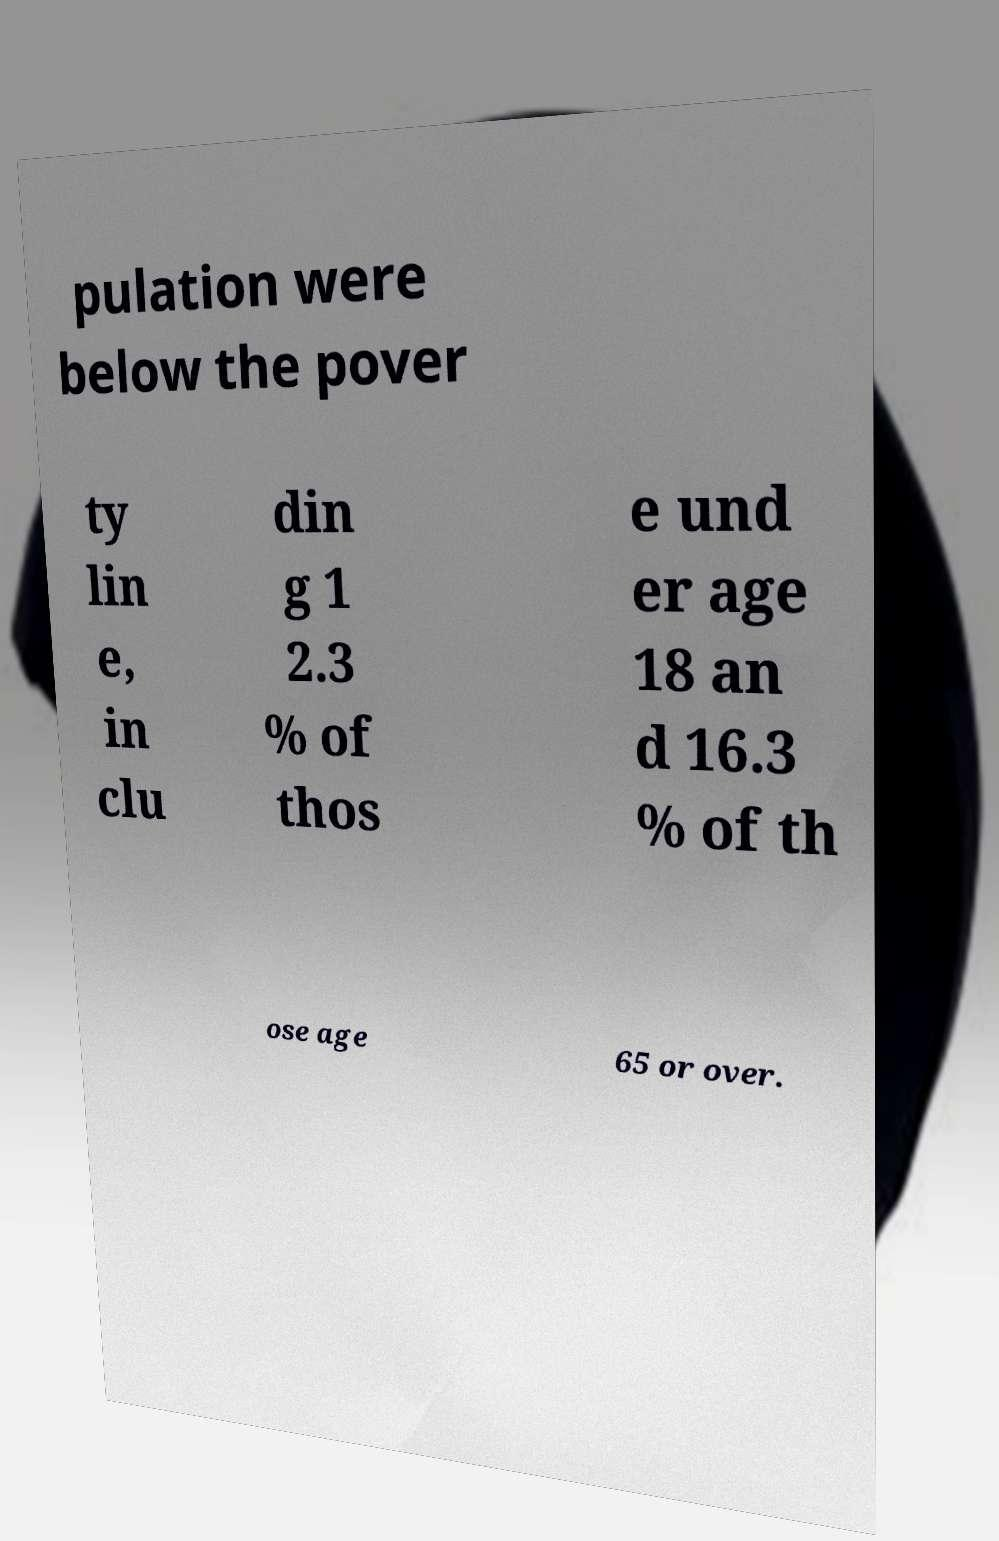What messages or text are displayed in this image? I need them in a readable, typed format. pulation were below the pover ty lin e, in clu din g 1 2.3 % of thos e und er age 18 an d 16.3 % of th ose age 65 or over. 